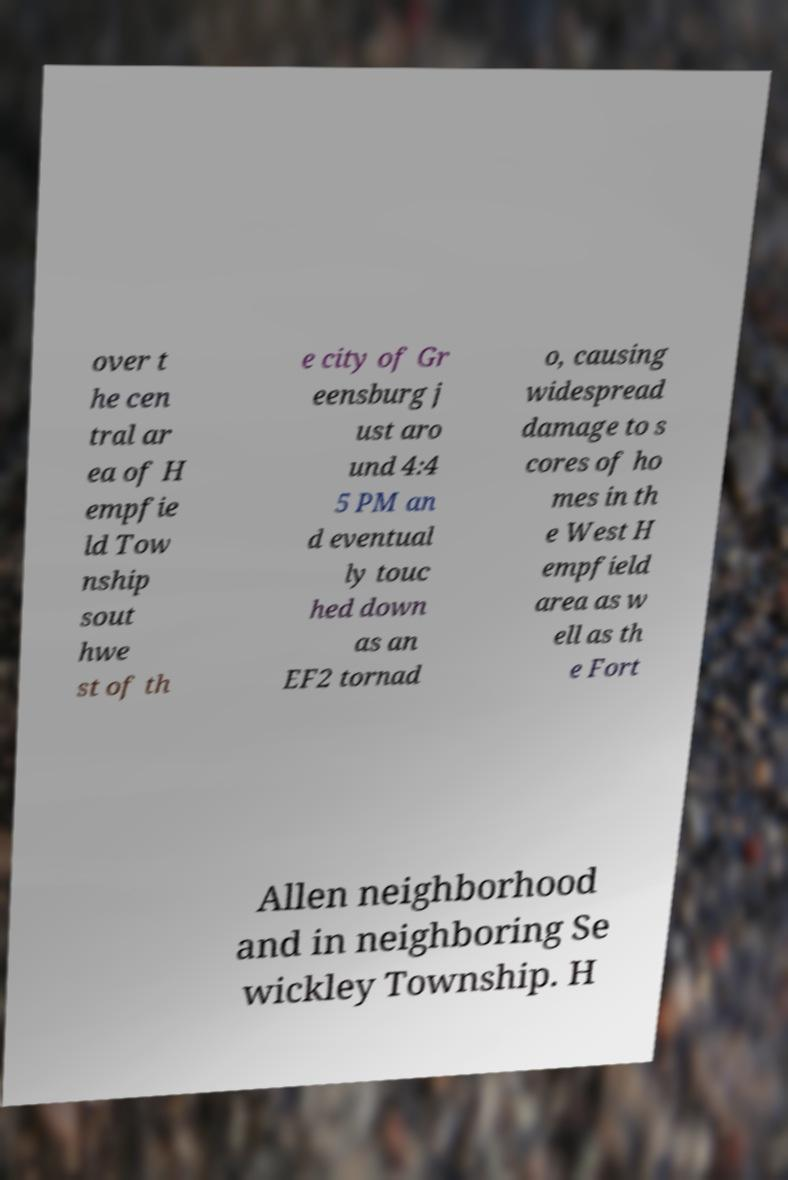For documentation purposes, I need the text within this image transcribed. Could you provide that? over t he cen tral ar ea of H empfie ld Tow nship sout hwe st of th e city of Gr eensburg j ust aro und 4:4 5 PM an d eventual ly touc hed down as an EF2 tornad o, causing widespread damage to s cores of ho mes in th e West H empfield area as w ell as th e Fort Allen neighborhood and in neighboring Se wickley Township. H 